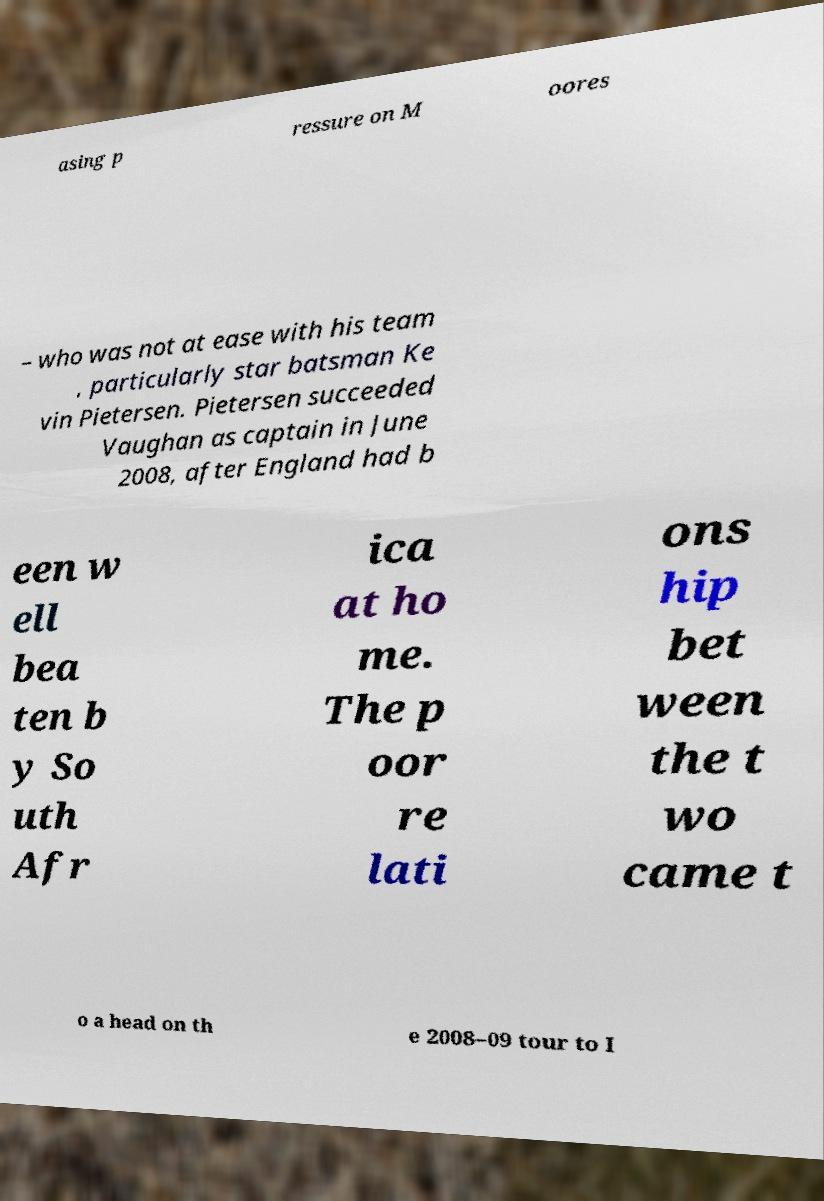Can you accurately transcribe the text from the provided image for me? asing p ressure on M oores – who was not at ease with his team , particularly star batsman Ke vin Pietersen. Pietersen succeeded Vaughan as captain in June 2008, after England had b een w ell bea ten b y So uth Afr ica at ho me. The p oor re lati ons hip bet ween the t wo came t o a head on th e 2008–09 tour to I 